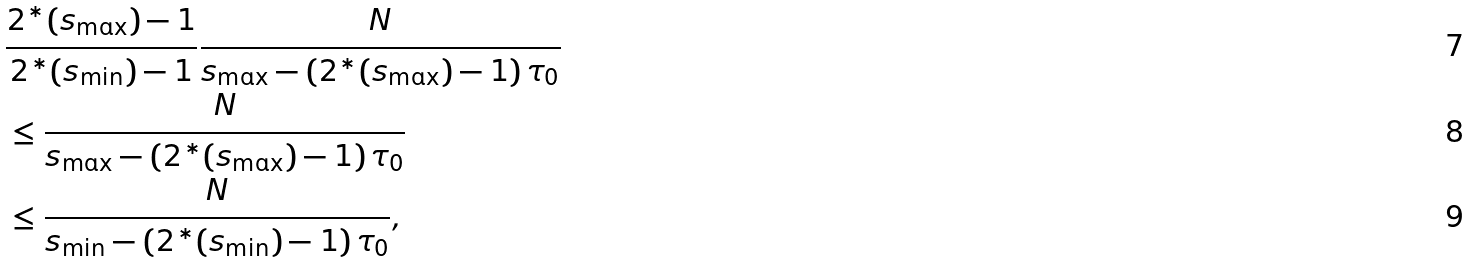Convert formula to latex. <formula><loc_0><loc_0><loc_500><loc_500>& \frac { 2 ^ { * } ( s _ { \max } ) - 1 } { 2 ^ { * } ( s _ { \min } ) - 1 } \frac { N } { s _ { \max } - \left ( 2 ^ { * } ( s _ { \max } ) - 1 \right ) \tau _ { 0 } } \\ & \leq \frac { N } { s _ { \max } - \left ( 2 ^ { * } ( s _ { \max } ) - 1 \right ) \tau _ { 0 } } \\ & \leq \frac { N } { s _ { \min } - \left ( 2 ^ { * } ( s _ { \min } ) - 1 \right ) \tau _ { 0 } } ,</formula> 